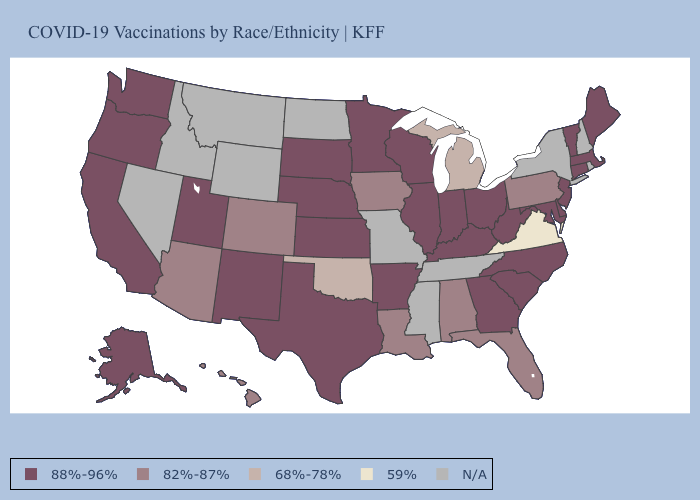What is the value of Texas?
Short answer required. 88%-96%. What is the lowest value in the West?
Be succinct. 82%-87%. Name the states that have a value in the range 68%-78%?
Concise answer only. Michigan, Oklahoma. Does the first symbol in the legend represent the smallest category?
Short answer required. No. What is the value of New Hampshire?
Be succinct. N/A. Does Arizona have the highest value in the West?
Concise answer only. No. Which states hav the highest value in the MidWest?
Answer briefly. Illinois, Indiana, Kansas, Minnesota, Nebraska, Ohio, South Dakota, Wisconsin. Name the states that have a value in the range 88%-96%?
Write a very short answer. Alaska, Arkansas, California, Connecticut, Delaware, Georgia, Illinois, Indiana, Kansas, Kentucky, Maine, Maryland, Massachusetts, Minnesota, Nebraska, New Jersey, New Mexico, North Carolina, Ohio, Oregon, South Carolina, South Dakota, Texas, Utah, Vermont, Washington, West Virginia, Wisconsin. What is the lowest value in the USA?
Short answer required. 59%. What is the highest value in the USA?
Give a very brief answer. 88%-96%. Does the first symbol in the legend represent the smallest category?
Short answer required. No. Among the states that border Utah , does New Mexico have the lowest value?
Quick response, please. No. What is the lowest value in the USA?
Short answer required. 59%. 